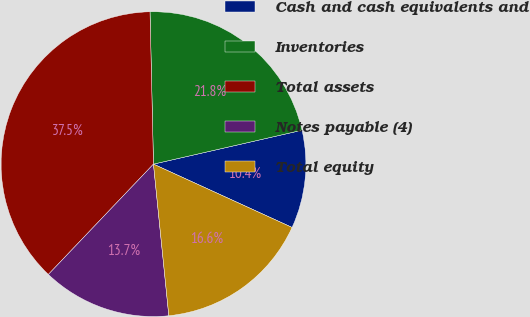<chart> <loc_0><loc_0><loc_500><loc_500><pie_chart><fcel>Cash and cash equivalents and<fcel>Inventories<fcel>Total assets<fcel>Notes payable (4)<fcel>Total equity<nl><fcel>10.39%<fcel>21.79%<fcel>37.52%<fcel>13.72%<fcel>16.57%<nl></chart> 